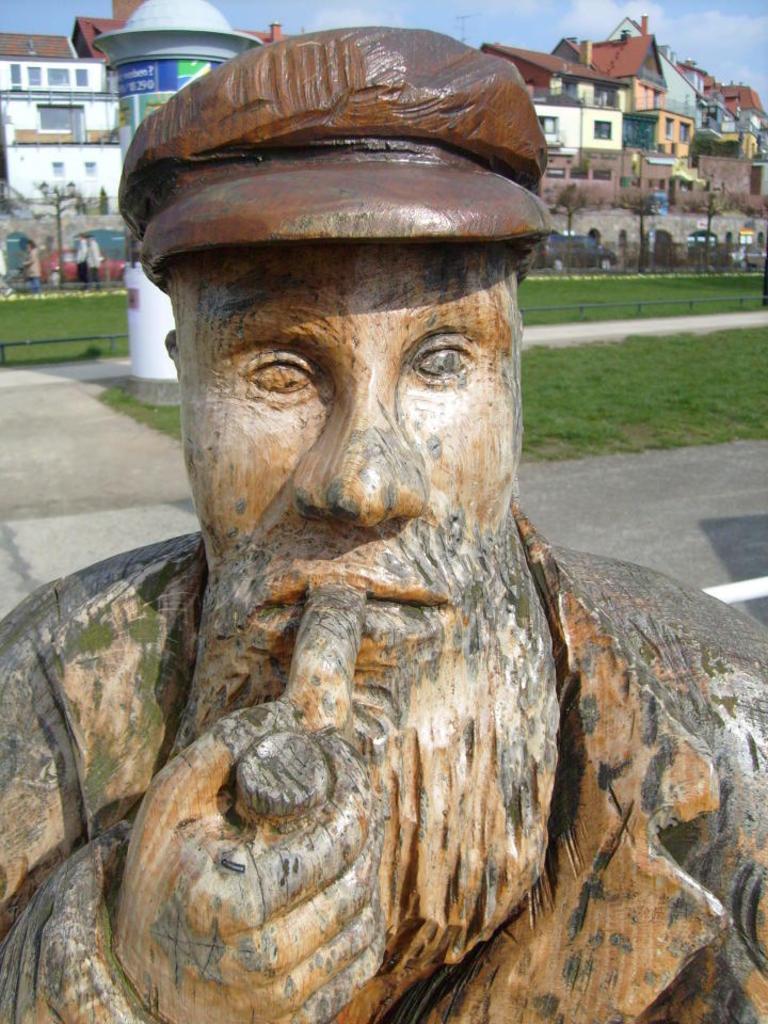Describe this image in one or two sentences. In the picture I can see the statue. In the background, I can see grass, buildings and people. There is a sky on the top of this image. 